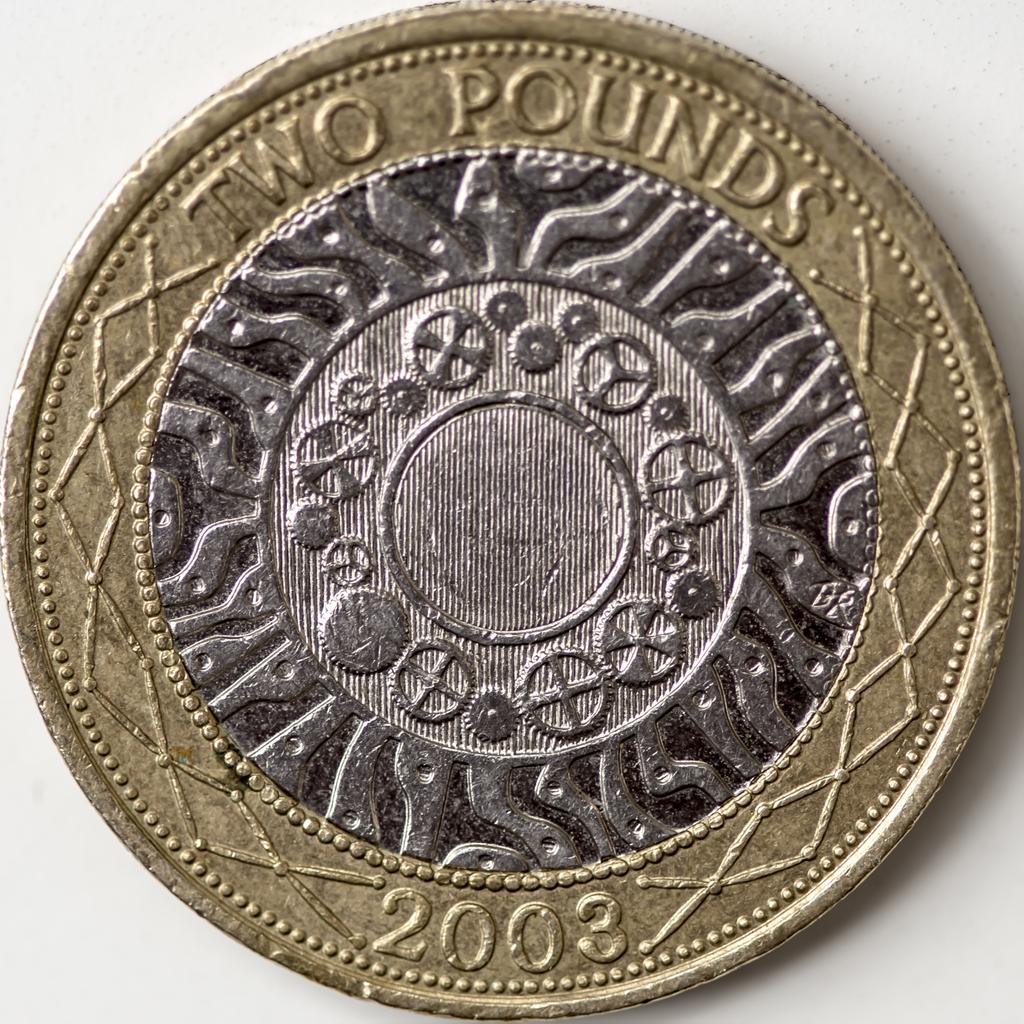What year was this made?
Provide a short and direct response. 2003. How many pounds is this?
Make the answer very short. 2. 